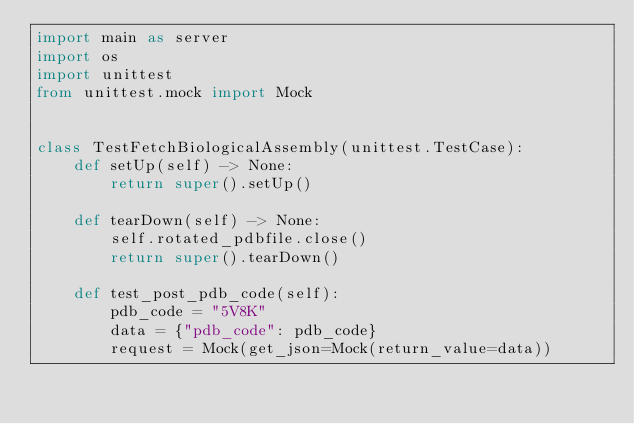<code> <loc_0><loc_0><loc_500><loc_500><_Python_>import main as server
import os
import unittest
from unittest.mock import Mock


class TestFetchBiologicalAssembly(unittest.TestCase):
    def setUp(self) -> None:
        return super().setUp()

    def tearDown(self) -> None:
        self.rotated_pdbfile.close()
        return super().tearDown()

    def test_post_pdb_code(self):
        pdb_code = "5V8K"
        data = {"pdb_code": pdb_code}
        request = Mock(get_json=Mock(return_value=data))
</code> 